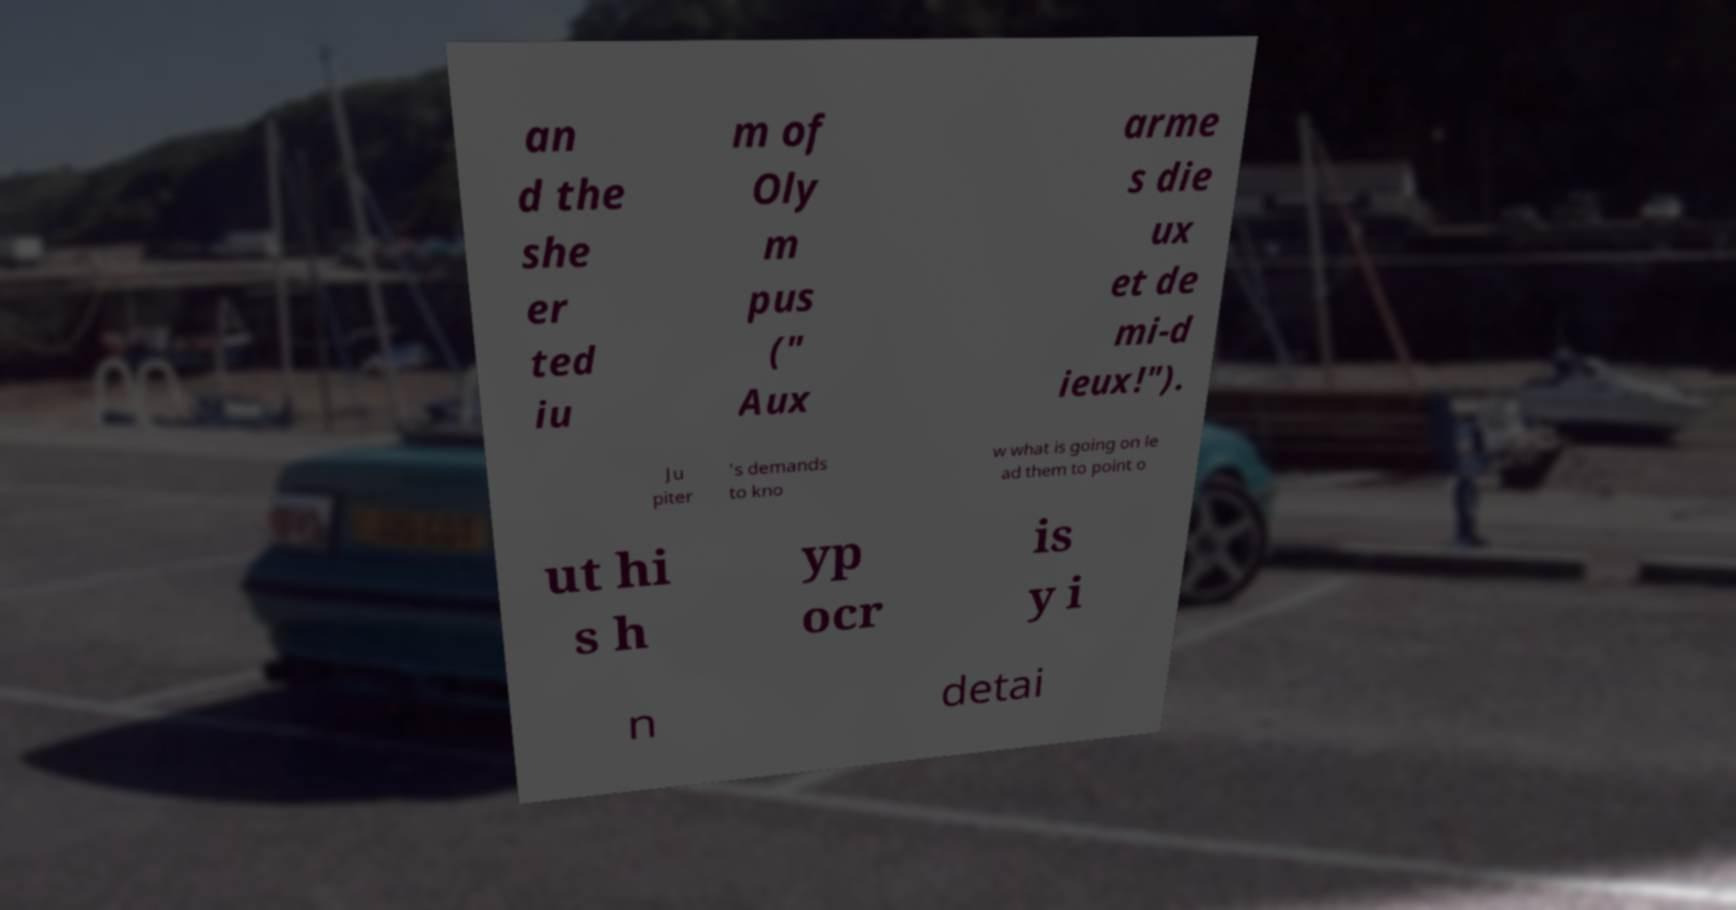Could you assist in decoding the text presented in this image and type it out clearly? an d the she er ted iu m of Oly m pus (" Aux arme s die ux et de mi-d ieux!"). Ju piter 's demands to kno w what is going on le ad them to point o ut hi s h yp ocr is y i n detai 